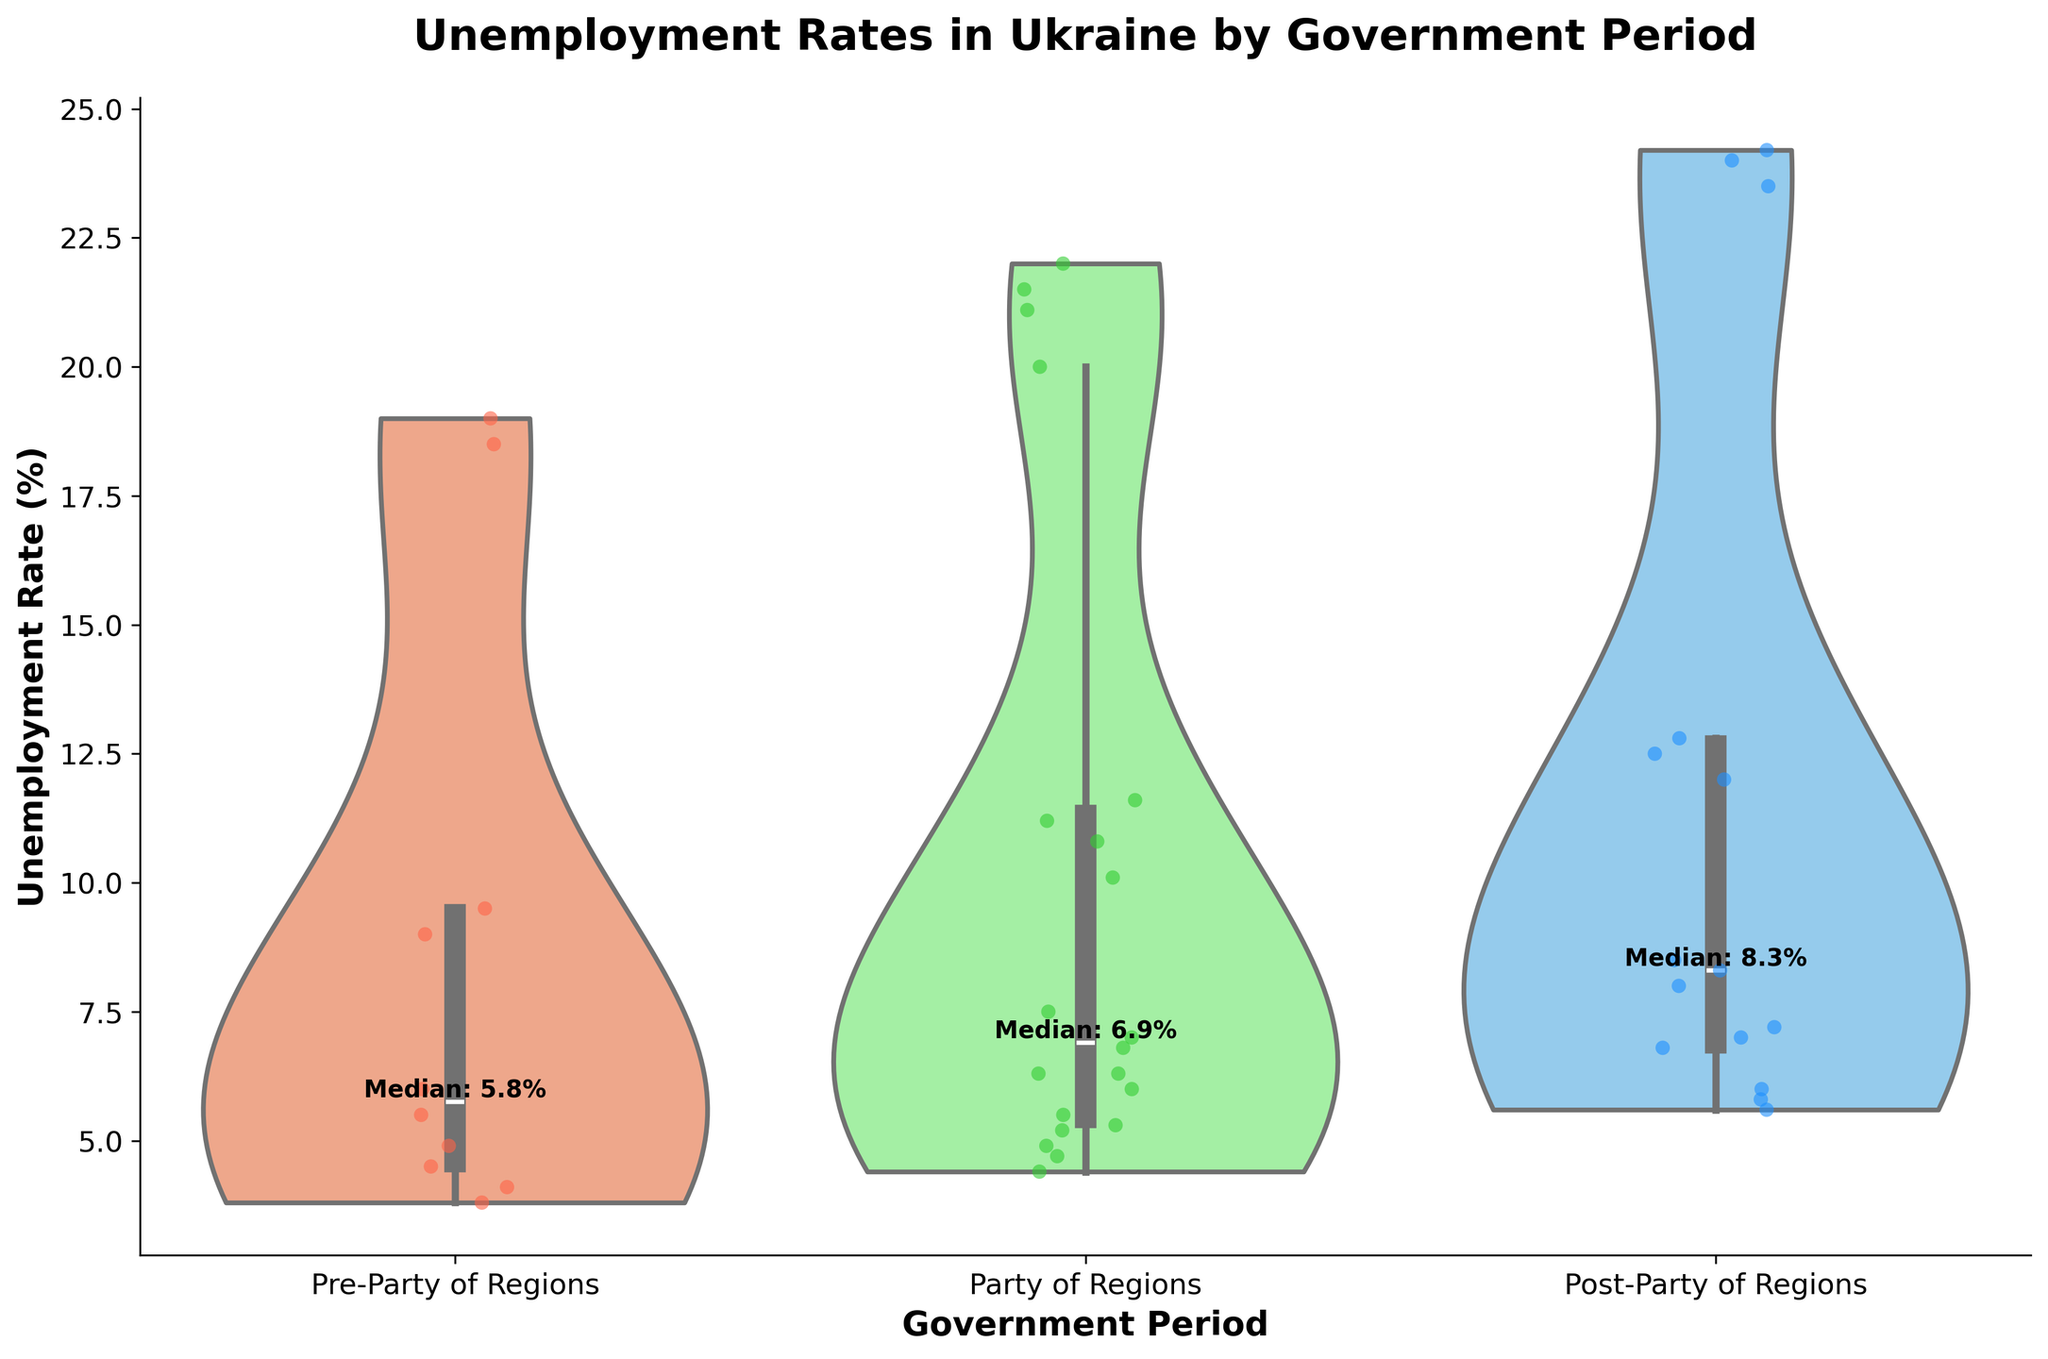What is the title of the chart? The title of the chart is displayed at the top and is used to summarize the main focus of the visualized data.
Answer: Unemployment Rates in Ukraine by Government Period What are the three government periods shown in the chart? The x-axis labels the three distinct periods of governance under which the data was collected.
Answer: Pre-Party of Regions, Party of Regions, Post-Party of Regions Which age group appears to have the highest median unemployment rate during the Party of Regions period? By examining the violin plots and the jittered points, we can determine which age group consistently appears to have the highest unemployment rates. The violin plot thickens towards the top for some age groups, indicating higher rates.
Answer: 15-24 How does the median unemployment rate change from the Pre-Party of Regions period to the Post-Party of Regions period for the age group 25-34? To find this, we would look at the y-values of the median lines (if marked) or general center points of the distributions for the specified age group in both periods.
Answer: Increases Compare the unemployment rate distribution during the Party of Regions period for the age groups 45-54 and 55-64. Which group has a wider distribution? Compare the spread of the violin plots for the age groups 45-54 and 55-64 during the Party of Regions period. The group with a wider spread indicates a more varied unemployment rate.
Answer: 45-54 What trend in unemployment rates do you observe for the age group 15-24 across different government periods? Analyze the placement and spread of the jittered points and the shape of the violin plots for the age group 15-24 across different periods to identify any trends.
Answer: Increasing What is the median unemployment rate for the Party of Regions period? Medians are often indicated by a line or a specific placement within the distribution of the violin plots. Additionally, text annotations might provide these values directly. Find the text or the middle of the violin plot for the Party of Regions period.
Answer: Approximately 7% How does the range of unemployment rates compare between the Pre-Party of Regions and Party of Regions periods for the age group 35-44? The range can be determined by the width of the violin plot from bottom to top for each period. Compare these ranges visually for the specified periods and age group.
Answer: Wider during Party of Regions 